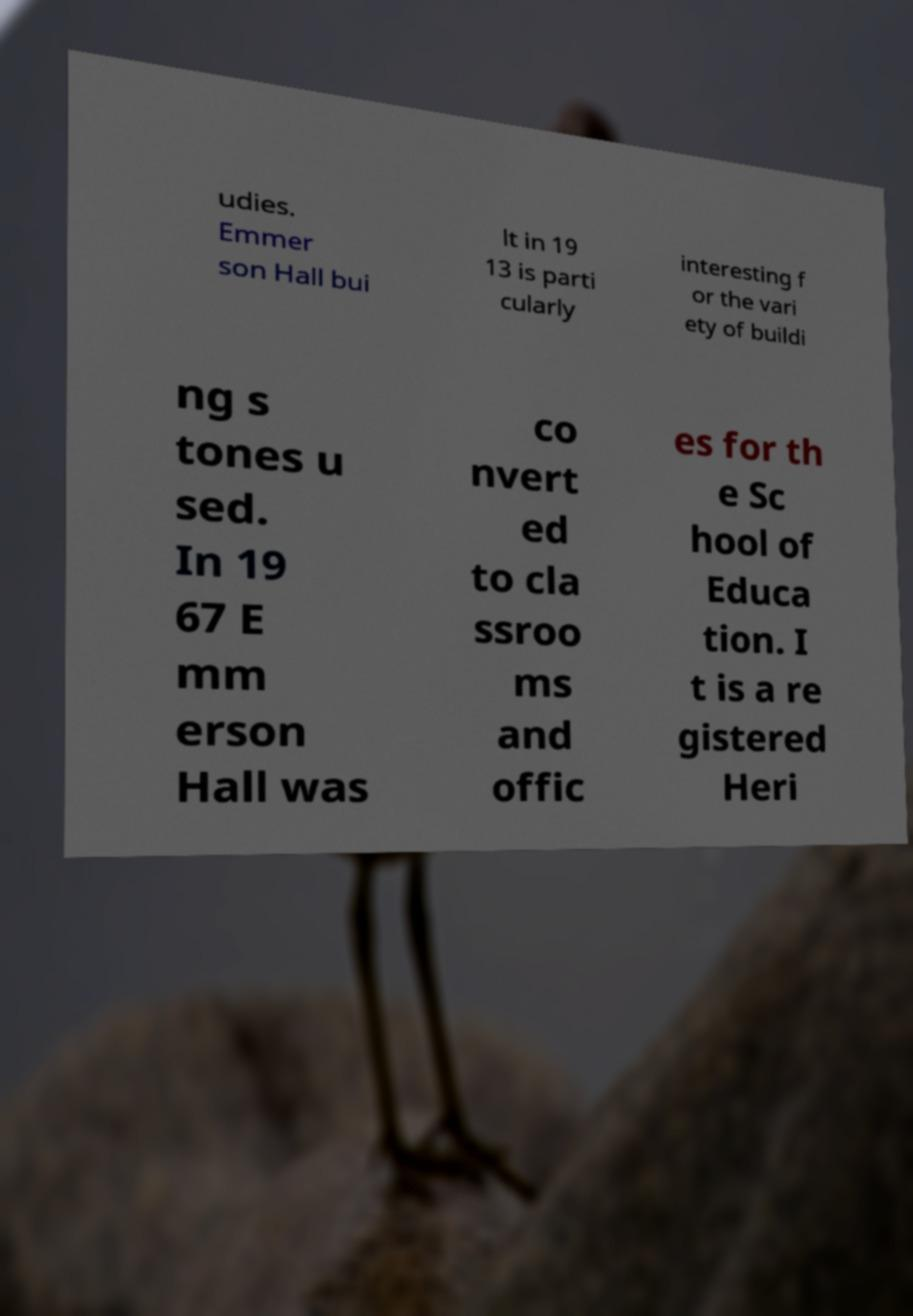What messages or text are displayed in this image? I need them in a readable, typed format. udies. Emmer son Hall bui lt in 19 13 is parti cularly interesting f or the vari ety of buildi ng s tones u sed. In 19 67 E mm erson Hall was co nvert ed to cla ssroo ms and offic es for th e Sc hool of Educa tion. I t is a re gistered Heri 